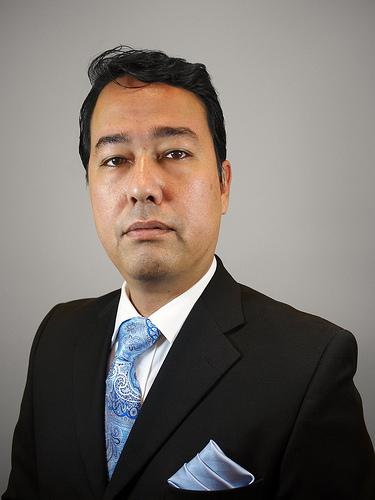Question: who is this?
Choices:
A. A woman.
B. Man.
C. Nelson Mandela.
D. Oprah.
Answer with the letter. Answer: B Question: what is he in?
Choices:
A. A bathing suit.
B. Suit.
C. Boxers.
D. A car.
Answer with the letter. Answer: B Question: why is he posing?
Choices:
A. To model.
B. He is showing off the car.
C. For his girlfriend.
D. Photo.
Answer with the letter. Answer: D 